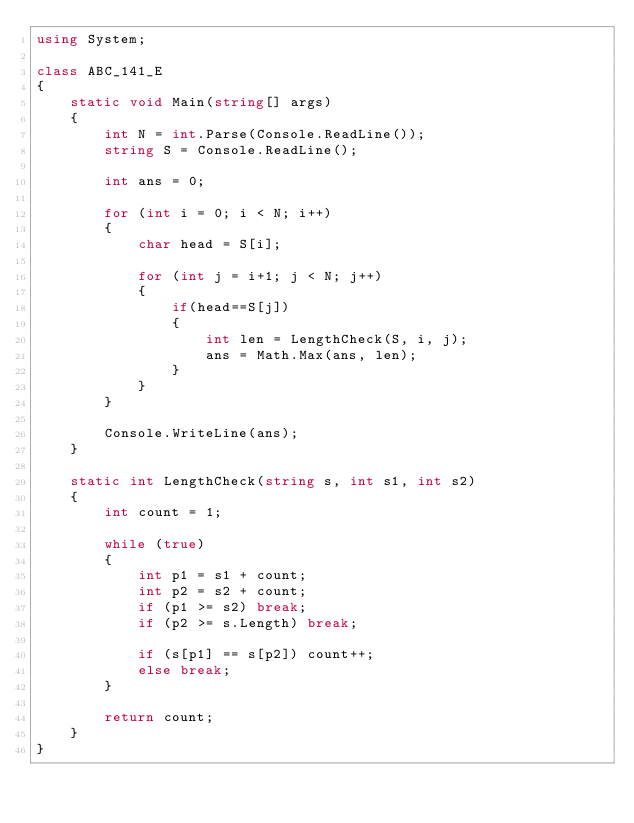<code> <loc_0><loc_0><loc_500><loc_500><_C#_>using System;

class ABC_141_E
{
    static void Main(string[] args)
    {
        int N = int.Parse(Console.ReadLine());
        string S = Console.ReadLine();

        int ans = 0;

        for (int i = 0; i < N; i++)
        {
            char head = S[i];

            for (int j = i+1; j < N; j++)
            {
                if(head==S[j])
                {
                    int len = LengthCheck(S, i, j);
                    ans = Math.Max(ans, len);
                }
            }
        }

        Console.WriteLine(ans);
    }

    static int LengthCheck(string s, int s1, int s2)
    {
        int count = 1;

        while (true)
        {
            int p1 = s1 + count;
            int p2 = s2 + count;
            if (p1 >= s2) break;
            if (p2 >= s.Length) break;

            if (s[p1] == s[p2]) count++;
            else break;
        }

        return count;
    }
}</code> 